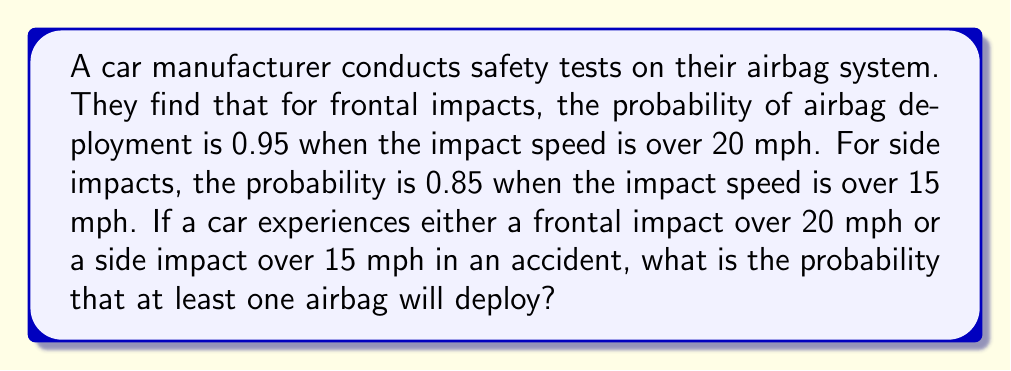Solve this math problem. Let's approach this step-by-step:

1) Let's define our events:
   F: Frontal impact over 20 mph
   S: Side impact over 15 mph
   A: At least one airbag deploys

2) We're given:
   P(A|F) = 0.95 (probability of airbag deployment given frontal impact)
   P(A|S) = 0.85 (probability of airbag deployment given side impact)

3) We want to find P(A|F or S), which is the probability of airbag deployment given either type of impact.

4) We can use the complement of this probability:
   P(A|F or S) = 1 - P(No airbag deploys|F or S)

5) For no airbag to deploy, it must not deploy in both scenarios:
   P(No airbag deploys|F or S) = (1 - P(A|F)) * (1 - P(A|S))

6) Let's calculate:
   P(No airbag deploys|F or S) = (1 - 0.95) * (1 - 0.85)
                                = 0.05 * 0.15
                                = 0.0075

7) Therefore:
   P(A|F or S) = 1 - 0.0075 = 0.9925

8) Converting to a percentage:
   0.9925 * 100 = 99.25%

Thus, there's a 99.25% chance that at least one airbag will deploy in this scenario.
Answer: 99.25% 